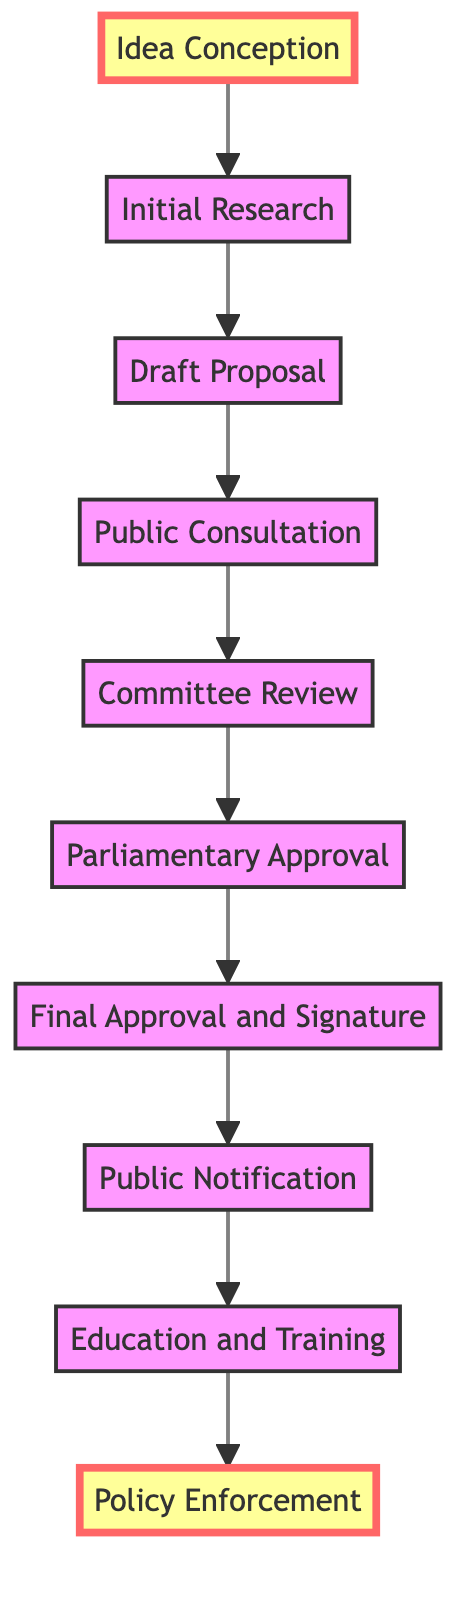What is the first step in the workflow? The first step is "Idea Conception," which indicates the initiation of the process.
Answer: Idea Conception How many total steps are there in the policy implementation workflow? There are 10 steps represented in the diagram, starting with "Idea Conception" and ending with "Policy Enforcement."
Answer: 10 What comes after "Public Consultation"? The step that follows "Public Consultation" is "Committee Review," where the proposal is reviewed and amended by a parliamentary committee.
Answer: Committee Review Which step involves training judges and court staff? The step dedicated to training judges, lawyers, and court staff is "Education and Training."
Answer: Education and Training What is the last step in the workflow? The final step in the workflow is "Policy Enforcement," which indicates the implementation of the finalized policy across the judicial system.
Answer: Policy Enforcement What is the relationship between "Final Approval and Signature" and "Parliamentary Approval"? "Final Approval and Signature" follows "Parliamentary Approval" as it occurs after the proposal is discussed and approved by the parliament.
Answer: Final Approval and Signature How is public feedback incorporated into the workflow? Public feedback is gathered during the "Public Consultation" step before the proposal moves on to the committee for review.
Answer: Public Consultation What type of experts are involved in creating the "Draft Proposal"? The "Draft Proposal" is prepared by a team of legal experts and policymakers, indicating specialized knowledge is required for this step.
Answer: Legal experts and policymakers Which three steps directly precede "Final Approval and Signature"? The three steps that come before "Final Approval and Signature" are "Parliamentary Approval," "Committee Review," and "Public Consultation," depicting a process of review and approval.
Answer: Parliamentary Approval, Committee Review, Public Consultation What is the main goal of the "Policy Enforcement" step? The primary goal of "Policy Enforcement" is to ensure that the finalized judicial policy is implemented and enforced effectively in the judicial system.
Answer: Implement and enforce the policy 